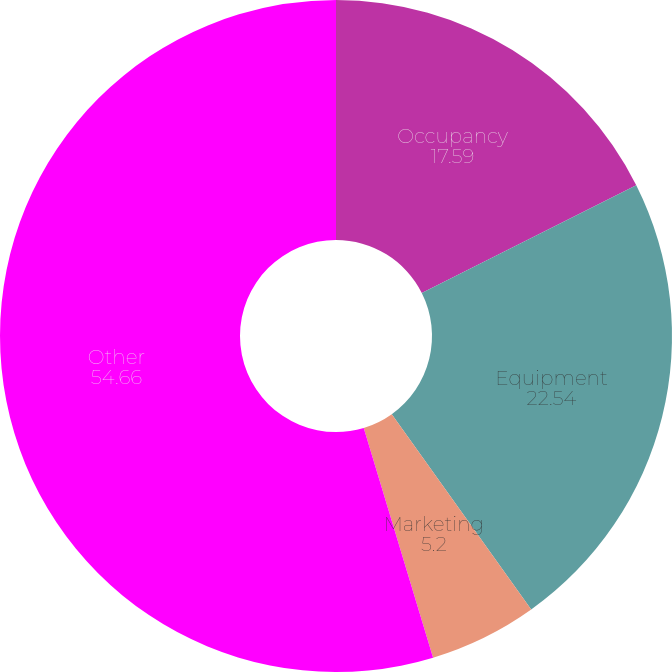Convert chart. <chart><loc_0><loc_0><loc_500><loc_500><pie_chart><fcel>Occupancy<fcel>Equipment<fcel>Marketing<fcel>Other<nl><fcel>17.59%<fcel>22.54%<fcel>5.2%<fcel>54.66%<nl></chart> 